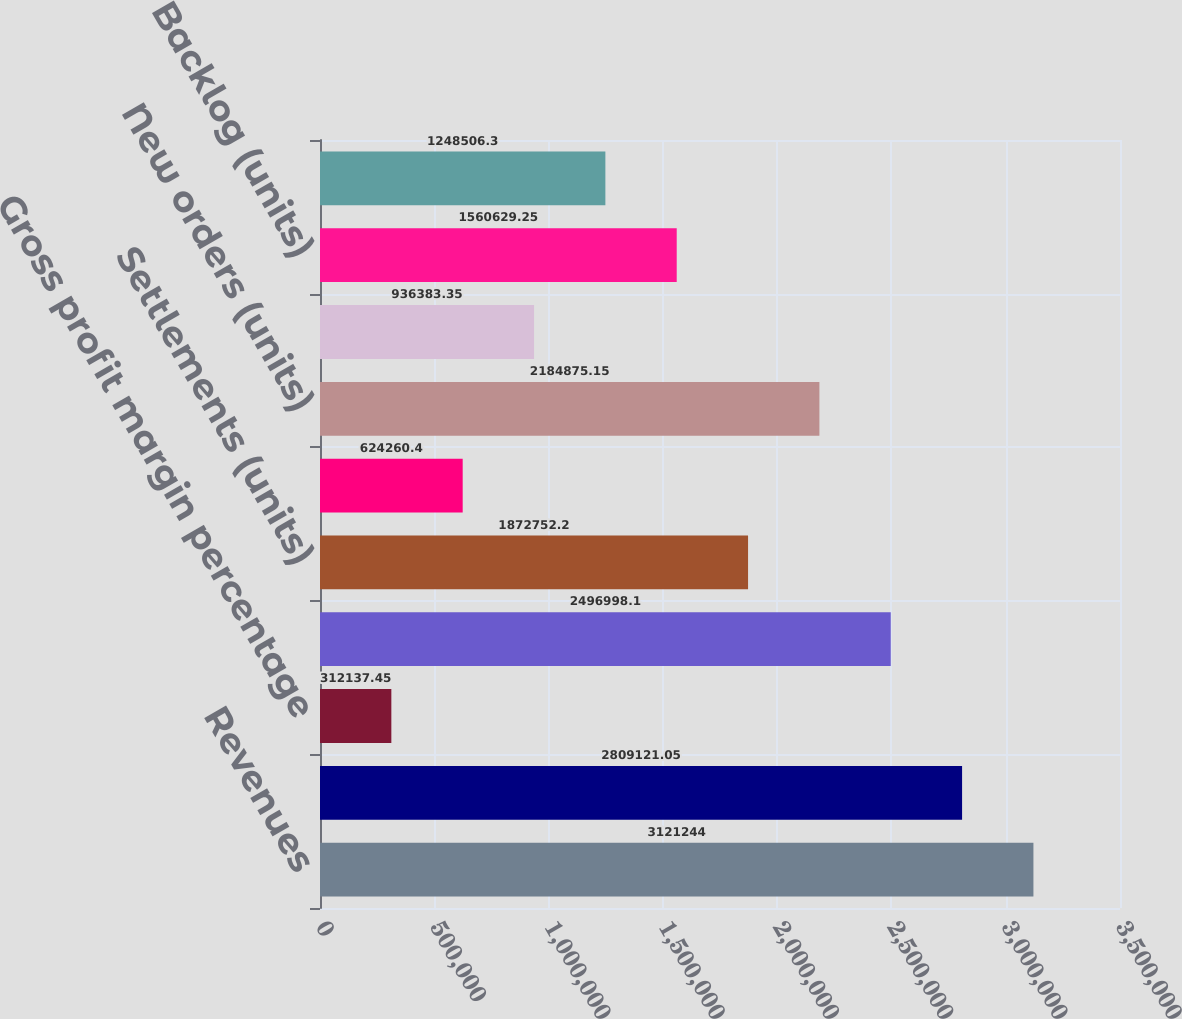Convert chart to OTSL. <chart><loc_0><loc_0><loc_500><loc_500><bar_chart><fcel>Revenues<fcel>Cost of sales<fcel>Gross profit margin percentage<fcel>Selling general and<fcel>Settlements (units)<fcel>Average settlement price<fcel>New orders (units)<fcel>Average new order price<fcel>Backlog (units)<fcel>Average backlog price<nl><fcel>3.12124e+06<fcel>2.80912e+06<fcel>312137<fcel>2.497e+06<fcel>1.87275e+06<fcel>624260<fcel>2.18488e+06<fcel>936383<fcel>1.56063e+06<fcel>1.24851e+06<nl></chart> 